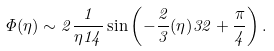<formula> <loc_0><loc_0><loc_500><loc_500>\Phi ( \eta ) \sim 2 \frac { 1 } { \eta ^ { } { 1 } 4 } \sin \left ( - \frac { 2 } { 3 } ( \eta ) ^ { } { 3 } 2 + \frac { \pi } { 4 } \right ) .</formula> 